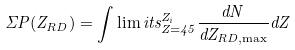Convert formula to latex. <formula><loc_0><loc_0><loc_500><loc_500>\Sigma P ( Z _ { R D } ) = \int \lim i t s _ { Z = 4 5 } ^ { Z _ { i } } \frac { d N } { d Z _ { R D , \max } } d Z</formula> 